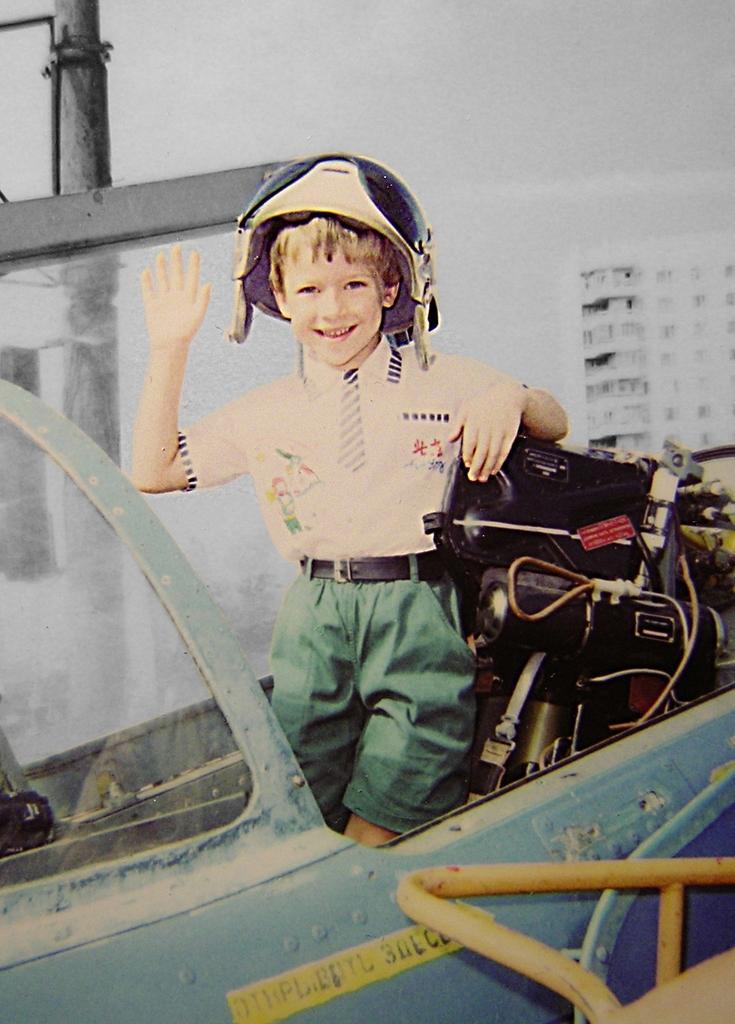Could you give a brief overview of what you see in this image? This image is an edited image. This image is taken outdoors. At the top of the image there is the sky. In the background there is a building and there is a pole. In the middle of the image a kid is standing in the vehicle and there are a few objects in the vehicle. The kid is with a smiling face. 